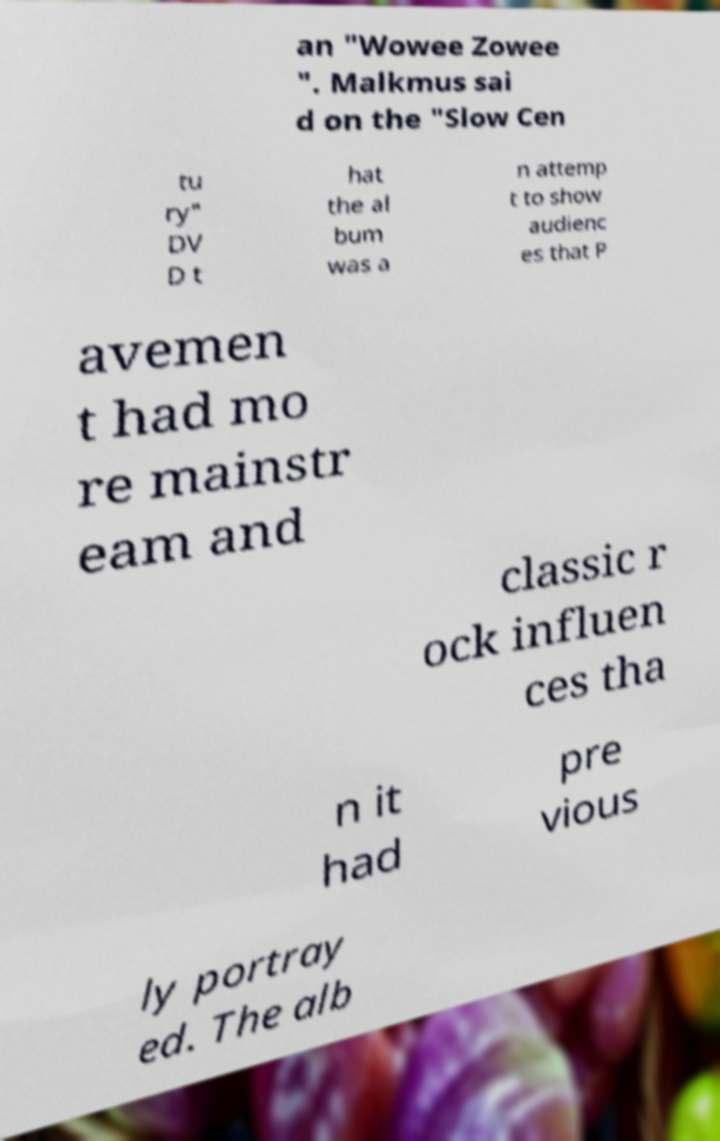There's text embedded in this image that I need extracted. Can you transcribe it verbatim? an "Wowee Zowee ". Malkmus sai d on the "Slow Cen tu ry" DV D t hat the al bum was a n attemp t to show audienc es that P avemen t had mo re mainstr eam and classic r ock influen ces tha n it had pre vious ly portray ed. The alb 